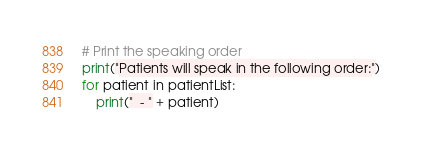Convert code to text. <code><loc_0><loc_0><loc_500><loc_500><_Python_>
# Print the speaking order
print("Patients will speak in the following order:")
for patient in patientList:
    print("  - " + patient)
</code> 